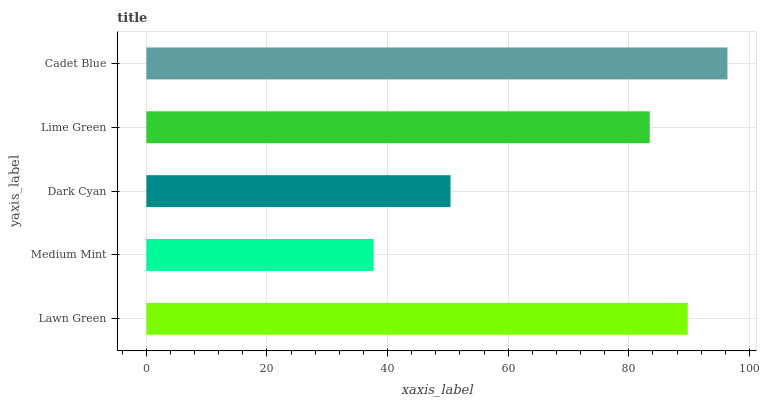Is Medium Mint the minimum?
Answer yes or no. Yes. Is Cadet Blue the maximum?
Answer yes or no. Yes. Is Dark Cyan the minimum?
Answer yes or no. No. Is Dark Cyan the maximum?
Answer yes or no. No. Is Dark Cyan greater than Medium Mint?
Answer yes or no. Yes. Is Medium Mint less than Dark Cyan?
Answer yes or no. Yes. Is Medium Mint greater than Dark Cyan?
Answer yes or no. No. Is Dark Cyan less than Medium Mint?
Answer yes or no. No. Is Lime Green the high median?
Answer yes or no. Yes. Is Lime Green the low median?
Answer yes or no. Yes. Is Medium Mint the high median?
Answer yes or no. No. Is Dark Cyan the low median?
Answer yes or no. No. 